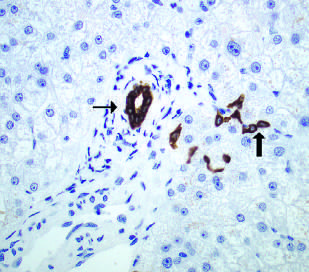what are bile duct cells and canals of hering stained here with for cytokeratin 7?
Answer the question using a single word or phrase. An immunohistochemical stain 